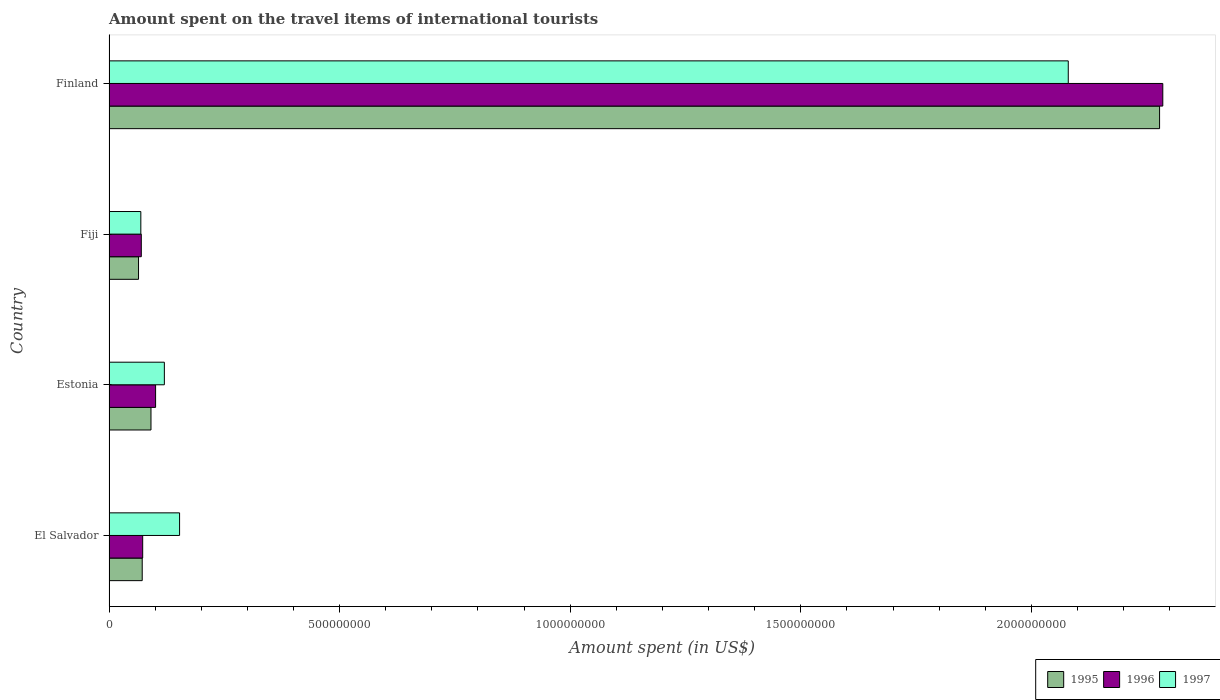How many different coloured bars are there?
Your response must be concise. 3. How many groups of bars are there?
Your answer should be very brief. 4. How many bars are there on the 2nd tick from the bottom?
Your response must be concise. 3. What is the label of the 3rd group of bars from the top?
Provide a short and direct response. Estonia. What is the amount spent on the travel items of international tourists in 1995 in Finland?
Offer a very short reply. 2.28e+09. Across all countries, what is the maximum amount spent on the travel items of international tourists in 1997?
Ensure brevity in your answer.  2.08e+09. Across all countries, what is the minimum amount spent on the travel items of international tourists in 1997?
Your answer should be compact. 6.90e+07. In which country was the amount spent on the travel items of international tourists in 1996 minimum?
Offer a very short reply. Fiji. What is the total amount spent on the travel items of international tourists in 1996 in the graph?
Keep it short and to the point. 2.53e+09. What is the difference between the amount spent on the travel items of international tourists in 1997 in Fiji and that in Finland?
Your answer should be very brief. -2.01e+09. What is the difference between the amount spent on the travel items of international tourists in 1997 in Estonia and the amount spent on the travel items of international tourists in 1995 in Fiji?
Offer a terse response. 5.60e+07. What is the average amount spent on the travel items of international tourists in 1997 per country?
Keep it short and to the point. 6.06e+08. What is the difference between the amount spent on the travel items of international tourists in 1995 and amount spent on the travel items of international tourists in 1996 in Fiji?
Ensure brevity in your answer.  -6.00e+06. In how many countries, is the amount spent on the travel items of international tourists in 1997 greater than 2200000000 US$?
Your response must be concise. 0. What is the ratio of the amount spent on the travel items of international tourists in 1995 in Estonia to that in Fiji?
Offer a very short reply. 1.42. Is the amount spent on the travel items of international tourists in 1995 in Estonia less than that in Finland?
Provide a short and direct response. Yes. Is the difference between the amount spent on the travel items of international tourists in 1995 in El Salvador and Fiji greater than the difference between the amount spent on the travel items of international tourists in 1996 in El Salvador and Fiji?
Provide a succinct answer. Yes. What is the difference between the highest and the second highest amount spent on the travel items of international tourists in 1997?
Your response must be concise. 1.93e+09. What is the difference between the highest and the lowest amount spent on the travel items of international tourists in 1996?
Give a very brief answer. 2.22e+09. In how many countries, is the amount spent on the travel items of international tourists in 1997 greater than the average amount spent on the travel items of international tourists in 1997 taken over all countries?
Your response must be concise. 1. Is the sum of the amount spent on the travel items of international tourists in 1995 in El Salvador and Finland greater than the maximum amount spent on the travel items of international tourists in 1997 across all countries?
Make the answer very short. Yes. Is it the case that in every country, the sum of the amount spent on the travel items of international tourists in 1997 and amount spent on the travel items of international tourists in 1996 is greater than the amount spent on the travel items of international tourists in 1995?
Provide a short and direct response. Yes. How many bars are there?
Provide a short and direct response. 12. Are all the bars in the graph horizontal?
Ensure brevity in your answer.  Yes. How many countries are there in the graph?
Offer a very short reply. 4. Does the graph contain grids?
Give a very brief answer. No. Where does the legend appear in the graph?
Provide a succinct answer. Bottom right. How many legend labels are there?
Make the answer very short. 3. What is the title of the graph?
Your answer should be very brief. Amount spent on the travel items of international tourists. Does "1994" appear as one of the legend labels in the graph?
Provide a succinct answer. No. What is the label or title of the X-axis?
Provide a succinct answer. Amount spent (in US$). What is the Amount spent (in US$) of 1995 in El Salvador?
Make the answer very short. 7.20e+07. What is the Amount spent (in US$) of 1996 in El Salvador?
Ensure brevity in your answer.  7.30e+07. What is the Amount spent (in US$) in 1997 in El Salvador?
Keep it short and to the point. 1.53e+08. What is the Amount spent (in US$) of 1995 in Estonia?
Keep it short and to the point. 9.10e+07. What is the Amount spent (in US$) of 1996 in Estonia?
Offer a very short reply. 1.01e+08. What is the Amount spent (in US$) of 1997 in Estonia?
Offer a very short reply. 1.20e+08. What is the Amount spent (in US$) of 1995 in Fiji?
Your answer should be very brief. 6.40e+07. What is the Amount spent (in US$) in 1996 in Fiji?
Ensure brevity in your answer.  7.00e+07. What is the Amount spent (in US$) in 1997 in Fiji?
Give a very brief answer. 6.90e+07. What is the Amount spent (in US$) of 1995 in Finland?
Your response must be concise. 2.28e+09. What is the Amount spent (in US$) in 1996 in Finland?
Offer a terse response. 2.28e+09. What is the Amount spent (in US$) of 1997 in Finland?
Your response must be concise. 2.08e+09. Across all countries, what is the maximum Amount spent (in US$) in 1995?
Make the answer very short. 2.28e+09. Across all countries, what is the maximum Amount spent (in US$) in 1996?
Give a very brief answer. 2.28e+09. Across all countries, what is the maximum Amount spent (in US$) in 1997?
Your answer should be compact. 2.08e+09. Across all countries, what is the minimum Amount spent (in US$) in 1995?
Make the answer very short. 6.40e+07. Across all countries, what is the minimum Amount spent (in US$) in 1996?
Your answer should be very brief. 7.00e+07. Across all countries, what is the minimum Amount spent (in US$) in 1997?
Keep it short and to the point. 6.90e+07. What is the total Amount spent (in US$) in 1995 in the graph?
Ensure brevity in your answer.  2.50e+09. What is the total Amount spent (in US$) in 1996 in the graph?
Ensure brevity in your answer.  2.53e+09. What is the total Amount spent (in US$) of 1997 in the graph?
Make the answer very short. 2.42e+09. What is the difference between the Amount spent (in US$) in 1995 in El Salvador and that in Estonia?
Make the answer very short. -1.90e+07. What is the difference between the Amount spent (in US$) of 1996 in El Salvador and that in Estonia?
Ensure brevity in your answer.  -2.80e+07. What is the difference between the Amount spent (in US$) in 1997 in El Salvador and that in Estonia?
Make the answer very short. 3.30e+07. What is the difference between the Amount spent (in US$) of 1996 in El Salvador and that in Fiji?
Ensure brevity in your answer.  3.00e+06. What is the difference between the Amount spent (in US$) of 1997 in El Salvador and that in Fiji?
Give a very brief answer. 8.40e+07. What is the difference between the Amount spent (in US$) in 1995 in El Salvador and that in Finland?
Give a very brief answer. -2.21e+09. What is the difference between the Amount spent (in US$) of 1996 in El Salvador and that in Finland?
Offer a very short reply. -2.21e+09. What is the difference between the Amount spent (in US$) in 1997 in El Salvador and that in Finland?
Your response must be concise. -1.93e+09. What is the difference between the Amount spent (in US$) of 1995 in Estonia and that in Fiji?
Your answer should be very brief. 2.70e+07. What is the difference between the Amount spent (in US$) of 1996 in Estonia and that in Fiji?
Make the answer very short. 3.10e+07. What is the difference between the Amount spent (in US$) in 1997 in Estonia and that in Fiji?
Provide a short and direct response. 5.10e+07. What is the difference between the Amount spent (in US$) in 1995 in Estonia and that in Finland?
Give a very brief answer. -2.19e+09. What is the difference between the Amount spent (in US$) in 1996 in Estonia and that in Finland?
Provide a short and direct response. -2.18e+09. What is the difference between the Amount spent (in US$) of 1997 in Estonia and that in Finland?
Keep it short and to the point. -1.96e+09. What is the difference between the Amount spent (in US$) in 1995 in Fiji and that in Finland?
Offer a very short reply. -2.21e+09. What is the difference between the Amount spent (in US$) of 1996 in Fiji and that in Finland?
Provide a succinct answer. -2.22e+09. What is the difference between the Amount spent (in US$) of 1997 in Fiji and that in Finland?
Your answer should be very brief. -2.01e+09. What is the difference between the Amount spent (in US$) in 1995 in El Salvador and the Amount spent (in US$) in 1996 in Estonia?
Offer a terse response. -2.90e+07. What is the difference between the Amount spent (in US$) in 1995 in El Salvador and the Amount spent (in US$) in 1997 in Estonia?
Offer a very short reply. -4.80e+07. What is the difference between the Amount spent (in US$) in 1996 in El Salvador and the Amount spent (in US$) in 1997 in Estonia?
Give a very brief answer. -4.70e+07. What is the difference between the Amount spent (in US$) in 1995 in El Salvador and the Amount spent (in US$) in 1996 in Fiji?
Provide a short and direct response. 2.00e+06. What is the difference between the Amount spent (in US$) in 1996 in El Salvador and the Amount spent (in US$) in 1997 in Fiji?
Your answer should be very brief. 4.00e+06. What is the difference between the Amount spent (in US$) of 1995 in El Salvador and the Amount spent (in US$) of 1996 in Finland?
Give a very brief answer. -2.21e+09. What is the difference between the Amount spent (in US$) in 1995 in El Salvador and the Amount spent (in US$) in 1997 in Finland?
Provide a succinct answer. -2.01e+09. What is the difference between the Amount spent (in US$) in 1996 in El Salvador and the Amount spent (in US$) in 1997 in Finland?
Provide a short and direct response. -2.01e+09. What is the difference between the Amount spent (in US$) of 1995 in Estonia and the Amount spent (in US$) of 1996 in Fiji?
Your answer should be compact. 2.10e+07. What is the difference between the Amount spent (in US$) in 1995 in Estonia and the Amount spent (in US$) in 1997 in Fiji?
Offer a very short reply. 2.20e+07. What is the difference between the Amount spent (in US$) of 1996 in Estonia and the Amount spent (in US$) of 1997 in Fiji?
Keep it short and to the point. 3.20e+07. What is the difference between the Amount spent (in US$) in 1995 in Estonia and the Amount spent (in US$) in 1996 in Finland?
Make the answer very short. -2.19e+09. What is the difference between the Amount spent (in US$) in 1995 in Estonia and the Amount spent (in US$) in 1997 in Finland?
Provide a succinct answer. -1.99e+09. What is the difference between the Amount spent (in US$) in 1996 in Estonia and the Amount spent (in US$) in 1997 in Finland?
Your response must be concise. -1.98e+09. What is the difference between the Amount spent (in US$) in 1995 in Fiji and the Amount spent (in US$) in 1996 in Finland?
Your answer should be compact. -2.22e+09. What is the difference between the Amount spent (in US$) of 1995 in Fiji and the Amount spent (in US$) of 1997 in Finland?
Offer a terse response. -2.02e+09. What is the difference between the Amount spent (in US$) of 1996 in Fiji and the Amount spent (in US$) of 1997 in Finland?
Ensure brevity in your answer.  -2.01e+09. What is the average Amount spent (in US$) in 1995 per country?
Offer a very short reply. 6.26e+08. What is the average Amount spent (in US$) in 1996 per country?
Offer a terse response. 6.32e+08. What is the average Amount spent (in US$) in 1997 per country?
Ensure brevity in your answer.  6.06e+08. What is the difference between the Amount spent (in US$) in 1995 and Amount spent (in US$) in 1997 in El Salvador?
Offer a very short reply. -8.10e+07. What is the difference between the Amount spent (in US$) of 1996 and Amount spent (in US$) of 1997 in El Salvador?
Offer a terse response. -8.00e+07. What is the difference between the Amount spent (in US$) in 1995 and Amount spent (in US$) in 1996 in Estonia?
Provide a succinct answer. -1.00e+07. What is the difference between the Amount spent (in US$) in 1995 and Amount spent (in US$) in 1997 in Estonia?
Your answer should be very brief. -2.90e+07. What is the difference between the Amount spent (in US$) of 1996 and Amount spent (in US$) of 1997 in Estonia?
Your response must be concise. -1.90e+07. What is the difference between the Amount spent (in US$) in 1995 and Amount spent (in US$) in 1996 in Fiji?
Offer a very short reply. -6.00e+06. What is the difference between the Amount spent (in US$) in 1995 and Amount spent (in US$) in 1997 in Fiji?
Ensure brevity in your answer.  -5.00e+06. What is the difference between the Amount spent (in US$) of 1995 and Amount spent (in US$) of 1996 in Finland?
Keep it short and to the point. -7.00e+06. What is the difference between the Amount spent (in US$) in 1995 and Amount spent (in US$) in 1997 in Finland?
Provide a short and direct response. 1.98e+08. What is the difference between the Amount spent (in US$) in 1996 and Amount spent (in US$) in 1997 in Finland?
Keep it short and to the point. 2.05e+08. What is the ratio of the Amount spent (in US$) of 1995 in El Salvador to that in Estonia?
Your response must be concise. 0.79. What is the ratio of the Amount spent (in US$) in 1996 in El Salvador to that in Estonia?
Give a very brief answer. 0.72. What is the ratio of the Amount spent (in US$) of 1997 in El Salvador to that in Estonia?
Your response must be concise. 1.27. What is the ratio of the Amount spent (in US$) of 1996 in El Salvador to that in Fiji?
Provide a short and direct response. 1.04. What is the ratio of the Amount spent (in US$) in 1997 in El Salvador to that in Fiji?
Ensure brevity in your answer.  2.22. What is the ratio of the Amount spent (in US$) of 1995 in El Salvador to that in Finland?
Offer a terse response. 0.03. What is the ratio of the Amount spent (in US$) in 1996 in El Salvador to that in Finland?
Provide a short and direct response. 0.03. What is the ratio of the Amount spent (in US$) of 1997 in El Salvador to that in Finland?
Provide a short and direct response. 0.07. What is the ratio of the Amount spent (in US$) of 1995 in Estonia to that in Fiji?
Provide a succinct answer. 1.42. What is the ratio of the Amount spent (in US$) in 1996 in Estonia to that in Fiji?
Provide a succinct answer. 1.44. What is the ratio of the Amount spent (in US$) of 1997 in Estonia to that in Fiji?
Offer a very short reply. 1.74. What is the ratio of the Amount spent (in US$) of 1995 in Estonia to that in Finland?
Your response must be concise. 0.04. What is the ratio of the Amount spent (in US$) in 1996 in Estonia to that in Finland?
Make the answer very short. 0.04. What is the ratio of the Amount spent (in US$) in 1997 in Estonia to that in Finland?
Your answer should be very brief. 0.06. What is the ratio of the Amount spent (in US$) of 1995 in Fiji to that in Finland?
Your response must be concise. 0.03. What is the ratio of the Amount spent (in US$) of 1996 in Fiji to that in Finland?
Provide a short and direct response. 0.03. What is the ratio of the Amount spent (in US$) of 1997 in Fiji to that in Finland?
Provide a succinct answer. 0.03. What is the difference between the highest and the second highest Amount spent (in US$) of 1995?
Ensure brevity in your answer.  2.19e+09. What is the difference between the highest and the second highest Amount spent (in US$) of 1996?
Offer a very short reply. 2.18e+09. What is the difference between the highest and the second highest Amount spent (in US$) of 1997?
Give a very brief answer. 1.93e+09. What is the difference between the highest and the lowest Amount spent (in US$) in 1995?
Provide a succinct answer. 2.21e+09. What is the difference between the highest and the lowest Amount spent (in US$) in 1996?
Give a very brief answer. 2.22e+09. What is the difference between the highest and the lowest Amount spent (in US$) of 1997?
Provide a short and direct response. 2.01e+09. 